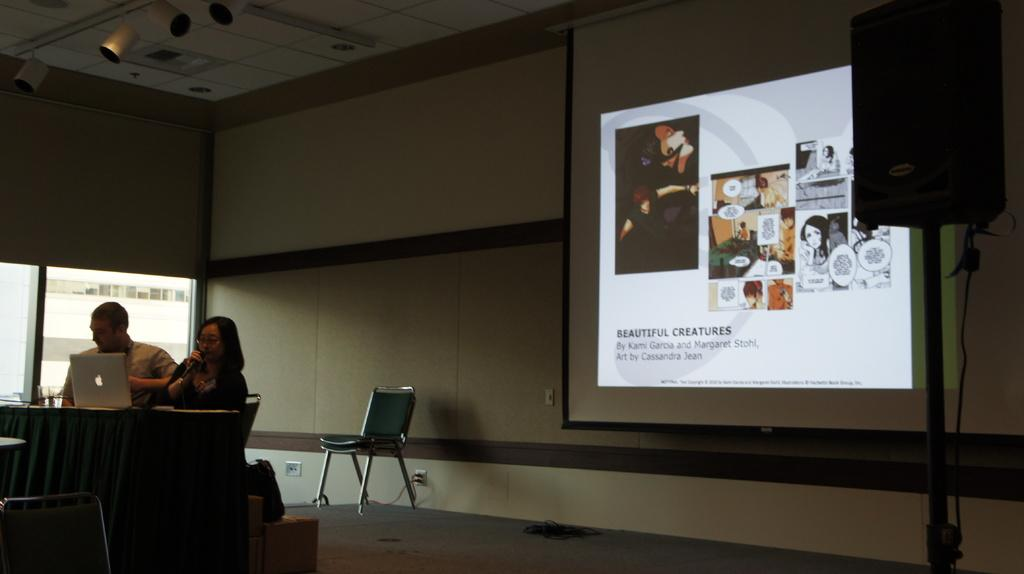How many people are in the image? There are two people in the image, a man and a woman. What are the man and woman doing in the image? They are sitting at a table desk and operating a laptop. What object is present behind the man and woman? There is a sound box behind them. What can be seen on the wall in the image? There is a screen displayed on the wall. What type of verse can be seen written on the window in the image? There is no window or verse present in the image. Can you describe the cat sitting on the woman's lap in the image? There is no cat present in the image. 